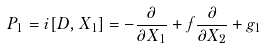<formula> <loc_0><loc_0><loc_500><loc_500>P _ { 1 } = i [ D , X _ { 1 } ] = - \frac { \partial } { \partial X _ { 1 } } + f \frac { \partial } { \partial X _ { 2 } } + g _ { 1 }</formula> 